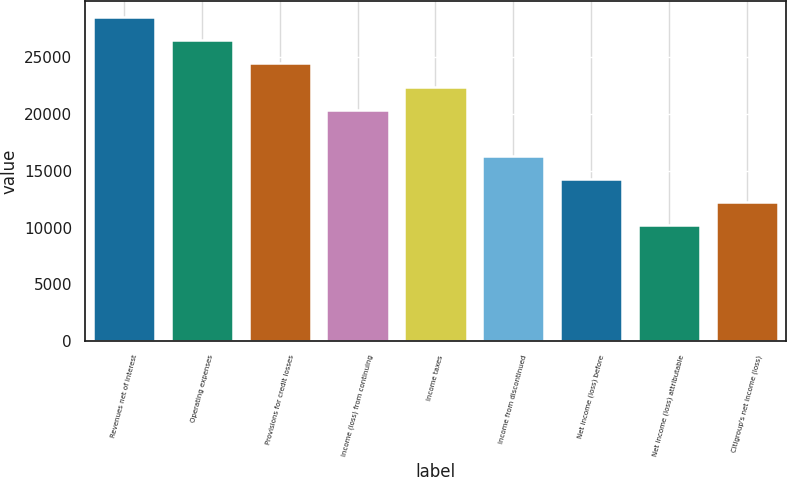Convert chart. <chart><loc_0><loc_0><loc_500><loc_500><bar_chart><fcel>Revenues net of interest<fcel>Operating expenses<fcel>Provisions for credit losses<fcel>Income (loss) from continuing<fcel>Income taxes<fcel>Income from discontinued<fcel>Net income (loss) before<fcel>Net income (loss) attributable<fcel>Citigroup's net income (loss)<nl><fcel>28546<fcel>26507<fcel>24468<fcel>20390<fcel>22429<fcel>16312.1<fcel>14273.1<fcel>10195.1<fcel>12234.1<nl></chart> 